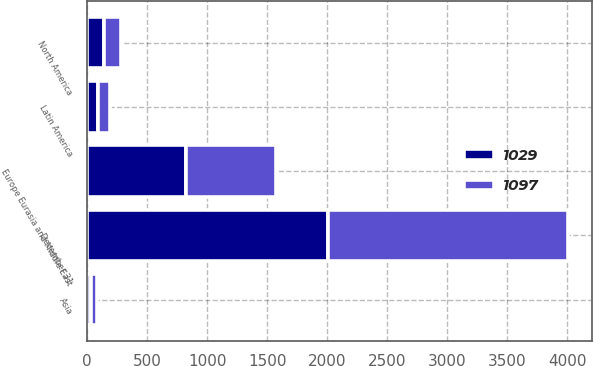<chart> <loc_0><loc_0><loc_500><loc_500><stacked_bar_chart><ecel><fcel>December 31<fcel>North America<fcel>Asia<fcel>Europe Eurasia and Middle East<fcel>Latin America<nl><fcel>1029<fcel>2004<fcel>140<fcel>37<fcel>828<fcel>92<nl><fcel>1097<fcel>2003<fcel>142<fcel>45<fcel>742<fcel>100<nl></chart> 